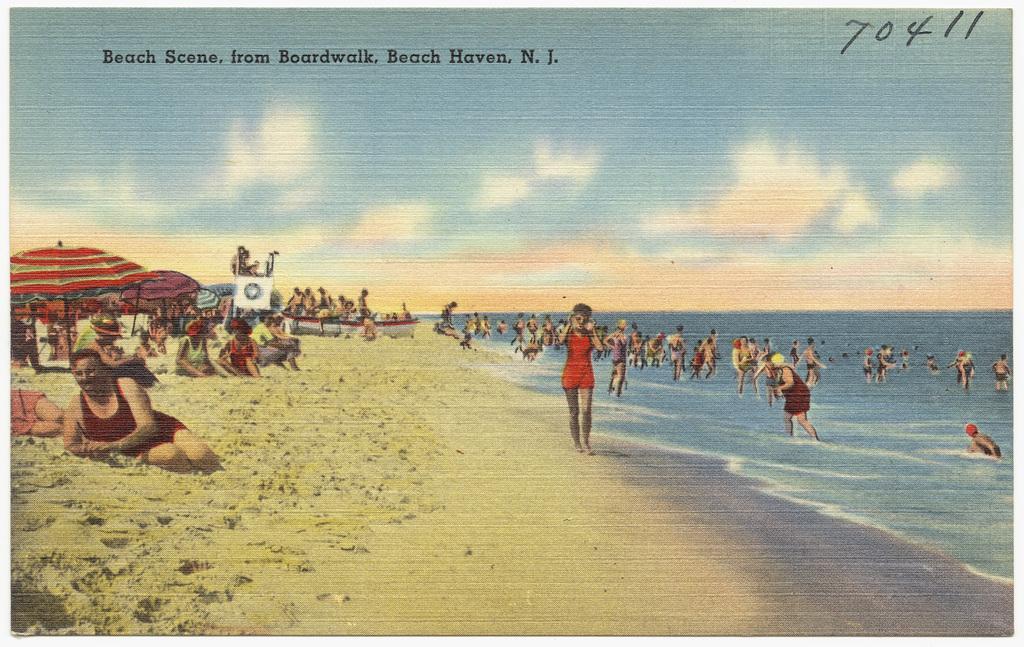Describe this image in one or two sentences. This is a painted image. We can see few persons are in the water on the right side and few persons are on the sand on the left side. We can also see umbrellas, objects and boat on the left side. In the background we can see clouds in the sky. At the top we can see texts written on the image. 